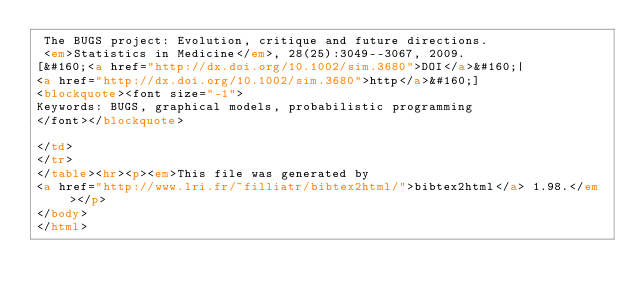<code> <loc_0><loc_0><loc_500><loc_500><_HTML_> The BUGS project: Evolution, critique and future directions.
 <em>Statistics in Medicine</em>, 28(25):3049--3067, 2009.
[&#160;<a href="http://dx.doi.org/10.1002/sim.3680">DOI</a>&#160;| 
<a href="http://dx.doi.org/10.1002/sim.3680">http</a>&#160;]
<blockquote><font size="-1">
Keywords: BUGS, graphical models, probabilistic programming
</font></blockquote>

</td>
</tr>
</table><hr><p><em>This file was generated by
<a href="http://www.lri.fr/~filliatr/bibtex2html/">bibtex2html</a> 1.98.</em></p>
</body>
</html></code> 